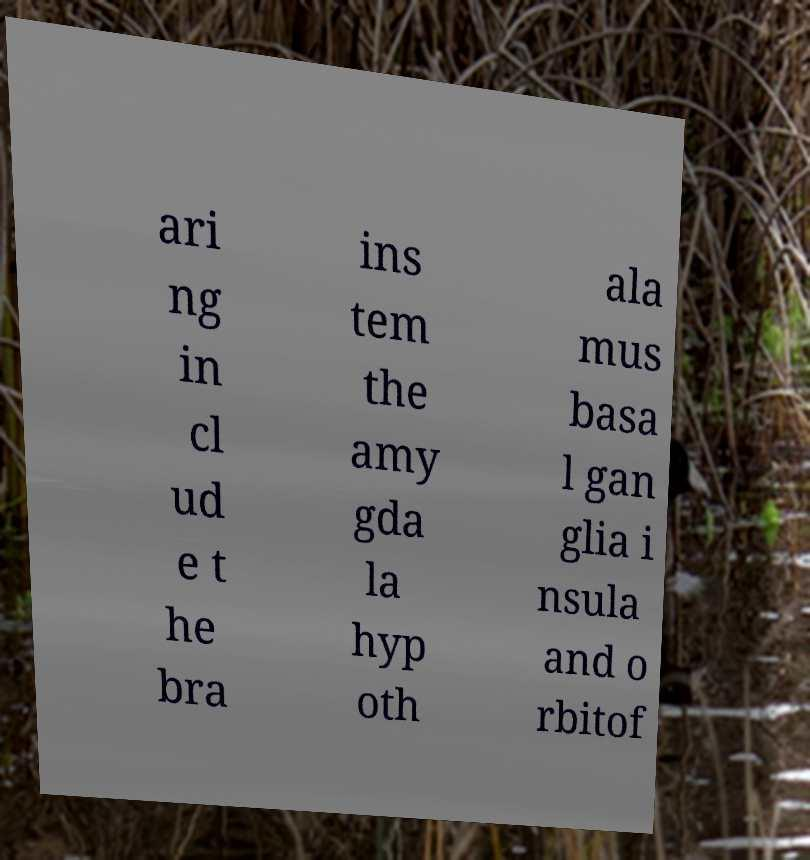For documentation purposes, I need the text within this image transcribed. Could you provide that? ari ng in cl ud e t he bra ins tem the amy gda la hyp oth ala mus basa l gan glia i nsula and o rbitof 